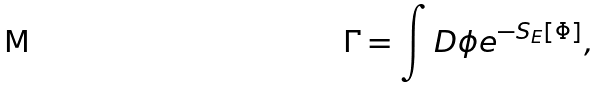<formula> <loc_0><loc_0><loc_500><loc_500>\Gamma = \int D \phi e ^ { - S _ { E } [ \Phi ] } ,</formula> 